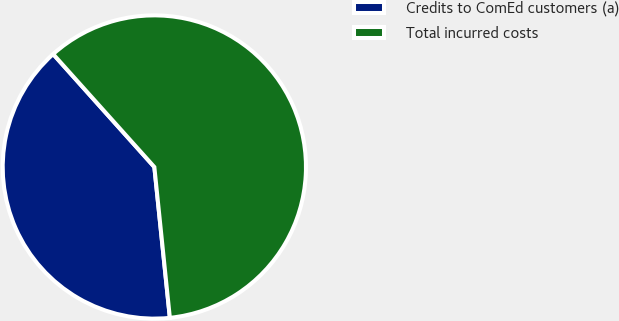Convert chart to OTSL. <chart><loc_0><loc_0><loc_500><loc_500><pie_chart><fcel>Credits to ComEd customers (a)<fcel>Total incurred costs<nl><fcel>40.0%<fcel>60.0%<nl></chart> 